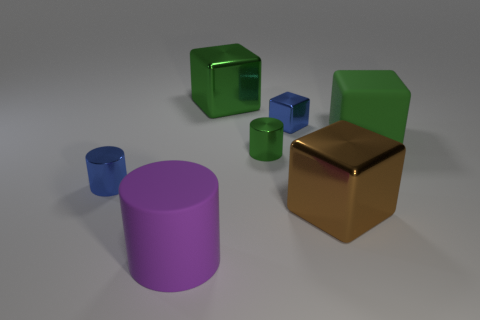Can you tell me the colors of the objects in the foreground and background? In the foreground, there is a large purple cylinder and a golden cube. In the background, starting from the left, there is a small blue cup, a medium-sized green cube, a small green cylinder, and a larger green cube with a hole in the center. 